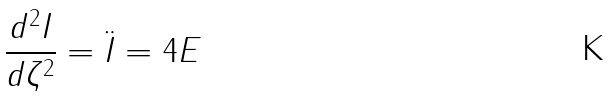<formula> <loc_0><loc_0><loc_500><loc_500>\frac { d ^ { 2 } I } { d \zeta ^ { 2 } } = \ddot { I } = 4 E</formula> 